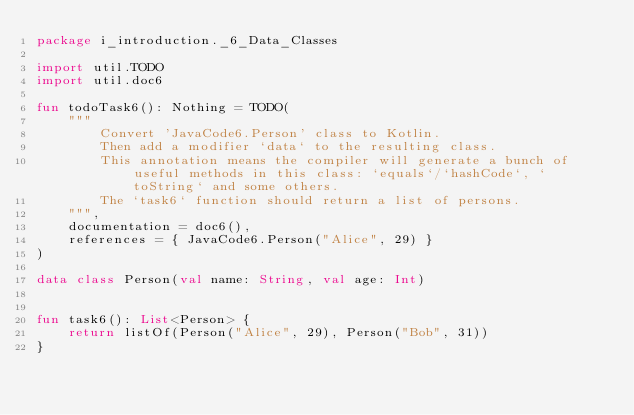Convert code to text. <code><loc_0><loc_0><loc_500><loc_500><_Kotlin_>package i_introduction._6_Data_Classes

import util.TODO
import util.doc6

fun todoTask6(): Nothing = TODO(
    """
        Convert 'JavaCode6.Person' class to Kotlin.
        Then add a modifier `data` to the resulting class.
        This annotation means the compiler will generate a bunch of useful methods in this class: `equals`/`hashCode`, `toString` and some others.
        The `task6` function should return a list of persons.
    """,
    documentation = doc6(),
    references = { JavaCode6.Person("Alice", 29) }
)

data class Person(val name: String, val age: Int)


fun task6(): List<Person> {
    return listOf(Person("Alice", 29), Person("Bob", 31))
}

</code> 